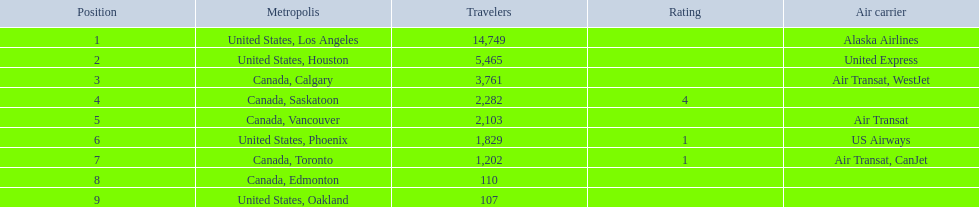What are the cities that are associated with the playa de oro international airport? United States, Los Angeles, United States, Houston, Canada, Calgary, Canada, Saskatoon, Canada, Vancouver, United States, Phoenix, Canada, Toronto, Canada, Edmonton, United States, Oakland. What is uniteed states, los angeles passenger count? 14,749. What other cities passenger count would lead to 19,000 roughly when combined with previous los angeles? Canada, Calgary. 